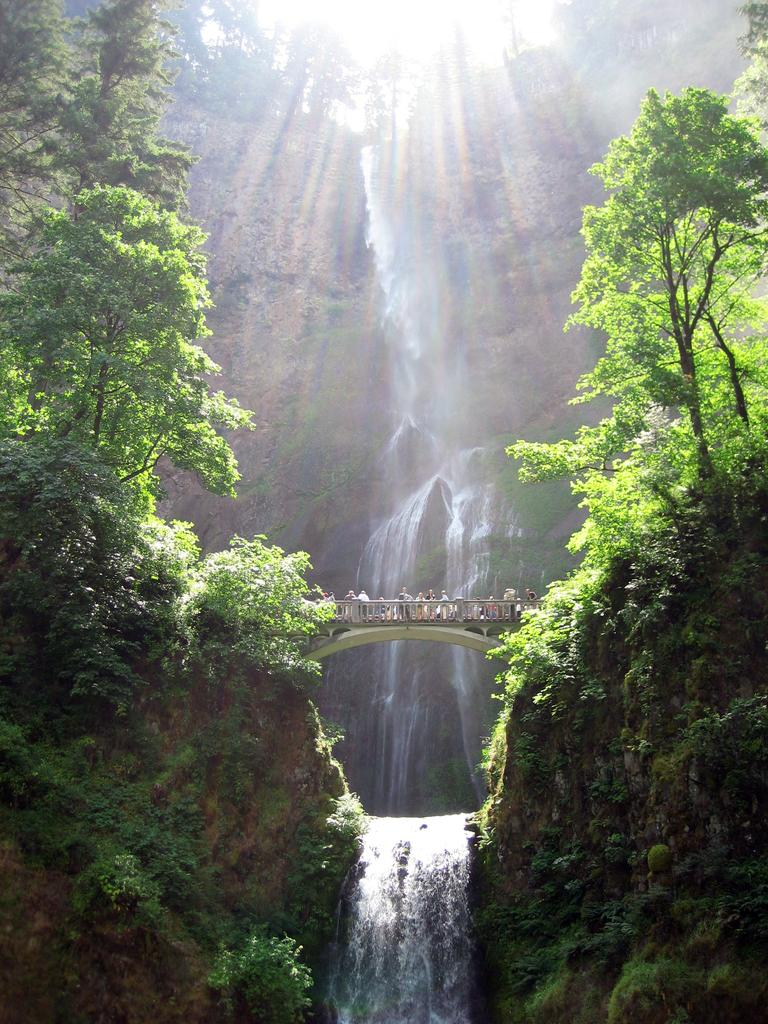What type of natural elements can be seen in the image? There are trees and a waterfall in the image. What man-made structure is present in the image? There is a bridge in the image. Are there any people visible in the image? Yes, there are people standing in the image. What type of neck can be seen on the waterfall in the image? There is no neck present on the waterfall in the image, as a waterfall is a natural feature and does not have a neck. 